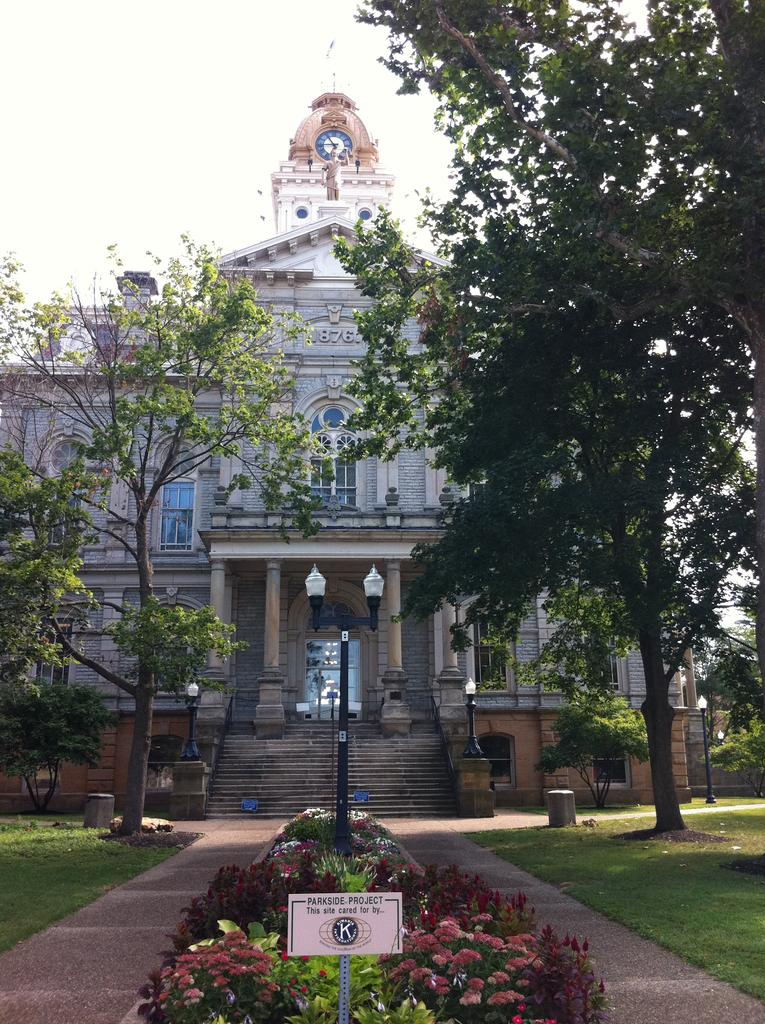Provide a one-sentence caption for the provided image. A building has a planted garden area in front of it with a plaque indicating it is a parkside project. 